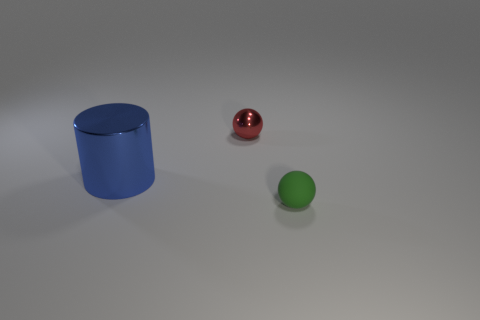Add 2 tiny metal cylinders. How many objects exist? 5 Subtract all balls. How many objects are left? 1 Subtract all red balls. How many balls are left? 1 Subtract 1 balls. How many balls are left? 1 Subtract all gray spheres. How many red cylinders are left? 0 Add 1 green rubber objects. How many green rubber objects are left? 2 Add 2 purple objects. How many purple objects exist? 2 Subtract 0 gray cubes. How many objects are left? 3 Subtract all yellow cylinders. Subtract all cyan spheres. How many cylinders are left? 1 Subtract all yellow things. Subtract all green objects. How many objects are left? 2 